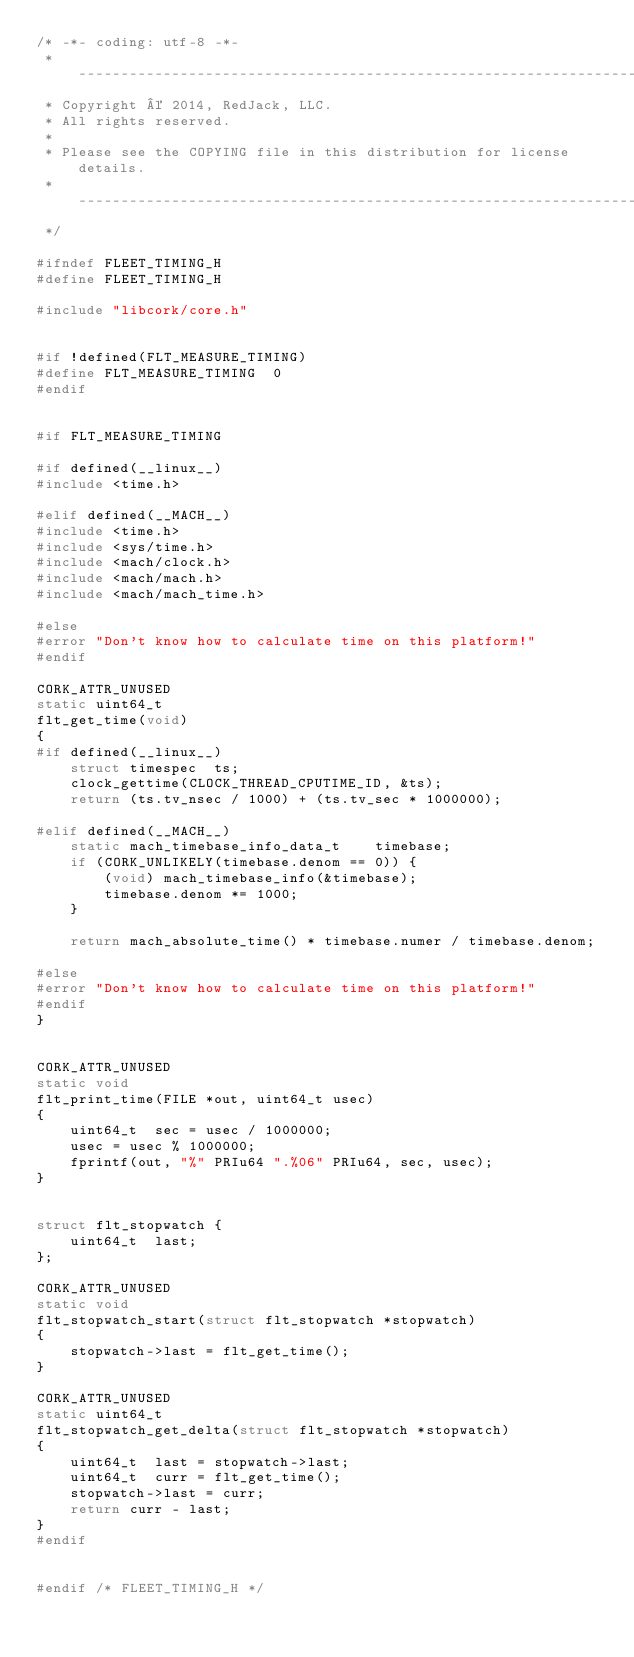<code> <loc_0><loc_0><loc_500><loc_500><_C_>/* -*- coding: utf-8 -*-
 * ----------------------------------------------------------------------
 * Copyright © 2014, RedJack, LLC.
 * All rights reserved.
 *
 * Please see the COPYING file in this distribution for license details.
 * ----------------------------------------------------------------------
 */

#ifndef FLEET_TIMING_H
#define FLEET_TIMING_H

#include "libcork/core.h"


#if !defined(FLT_MEASURE_TIMING)
#define FLT_MEASURE_TIMING  0
#endif


#if FLT_MEASURE_TIMING

#if defined(__linux__)
#include <time.h>

#elif defined(__MACH__)
#include <time.h>
#include <sys/time.h>
#include <mach/clock.h>
#include <mach/mach.h>
#include <mach/mach_time.h>

#else
#error "Don't know how to calculate time on this platform!"
#endif

CORK_ATTR_UNUSED
static uint64_t
flt_get_time(void)
{
#if defined(__linux__)
    struct timespec  ts;
    clock_gettime(CLOCK_THREAD_CPUTIME_ID, &ts);
    return (ts.tv_nsec / 1000) + (ts.tv_sec * 1000000);

#elif defined(__MACH__)
    static mach_timebase_info_data_t    timebase;
    if (CORK_UNLIKELY(timebase.denom == 0)) {
        (void) mach_timebase_info(&timebase);
        timebase.denom *= 1000;
    }

    return mach_absolute_time() * timebase.numer / timebase.denom;

#else
#error "Don't know how to calculate time on this platform!"
#endif
}


CORK_ATTR_UNUSED
static void
flt_print_time(FILE *out, uint64_t usec)
{
    uint64_t  sec = usec / 1000000;
    usec = usec % 1000000;
    fprintf(out, "%" PRIu64 ".%06" PRIu64, sec, usec);
}


struct flt_stopwatch {
    uint64_t  last;
};

CORK_ATTR_UNUSED
static void
flt_stopwatch_start(struct flt_stopwatch *stopwatch)
{
    stopwatch->last = flt_get_time();
}

CORK_ATTR_UNUSED
static uint64_t
flt_stopwatch_get_delta(struct flt_stopwatch *stopwatch)
{
    uint64_t  last = stopwatch->last;
    uint64_t  curr = flt_get_time();
    stopwatch->last = curr;
    return curr - last;
}
#endif


#endif /* FLEET_TIMING_H */
</code> 